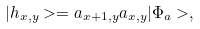<formula> <loc_0><loc_0><loc_500><loc_500>| h _ { x , y } > = a _ { x + 1 , y } a _ { x , y } | \Phi _ { a } > ,</formula> 